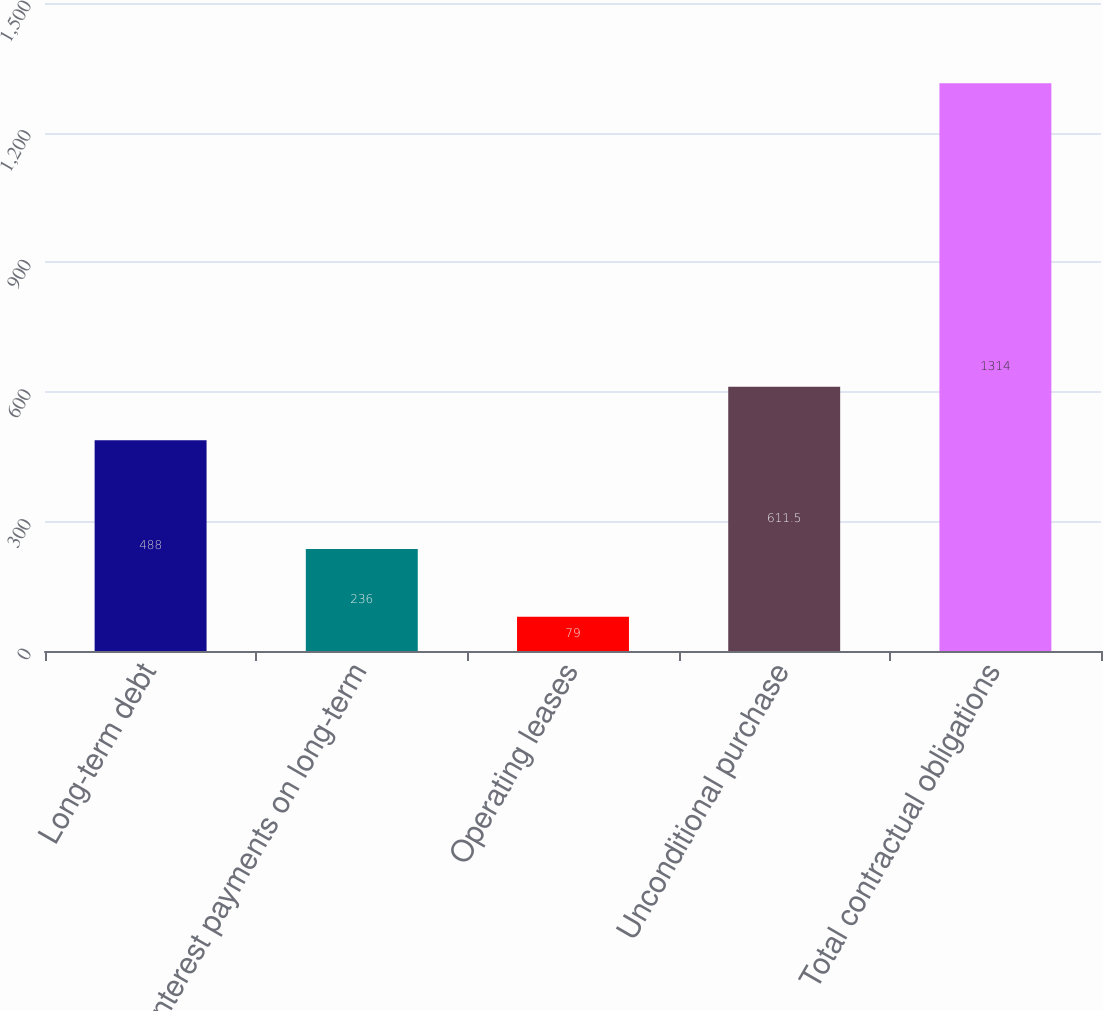Convert chart. <chart><loc_0><loc_0><loc_500><loc_500><bar_chart><fcel>Long-term debt<fcel>Interest payments on long-term<fcel>Operating leases<fcel>Unconditional purchase<fcel>Total contractual obligations<nl><fcel>488<fcel>236<fcel>79<fcel>611.5<fcel>1314<nl></chart> 